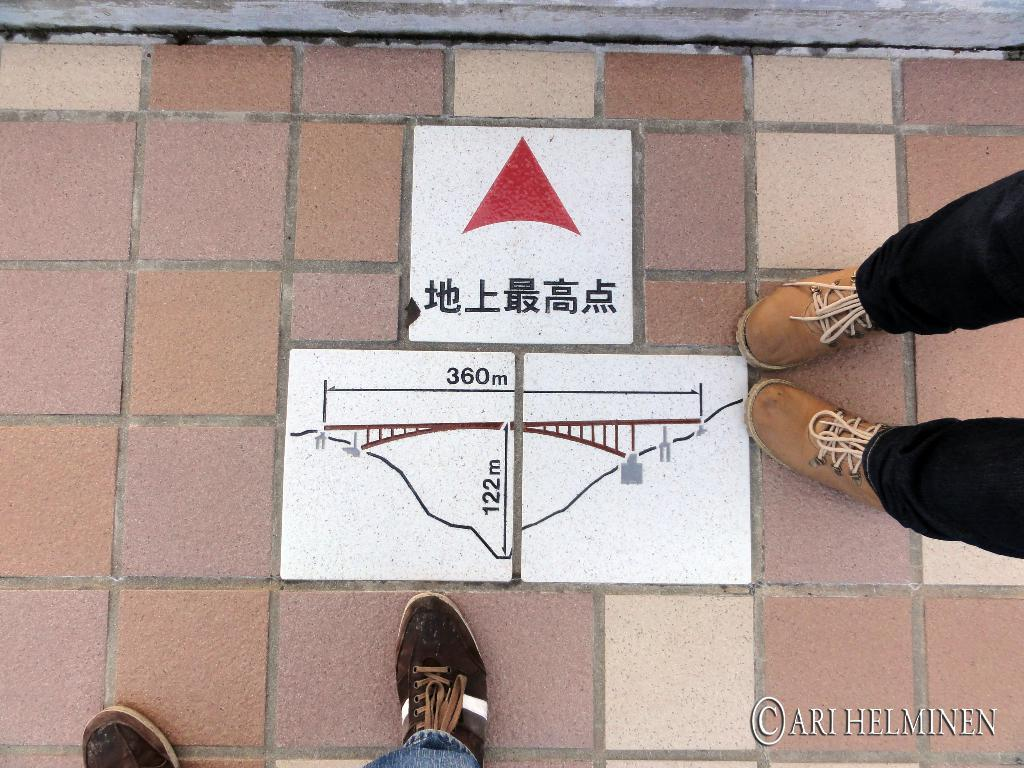What body parts are visible in the image? There are persons' legs visible on a surface. What type of footwear is present in the image? Worn footwear is present. What can be seen on the white surface in the image? There are measurements on the white surface. How many fish are swimming in the yard in the image? There are no fish or yards present in the image; it features legs, worn footwear, and measurements on a white surface. 